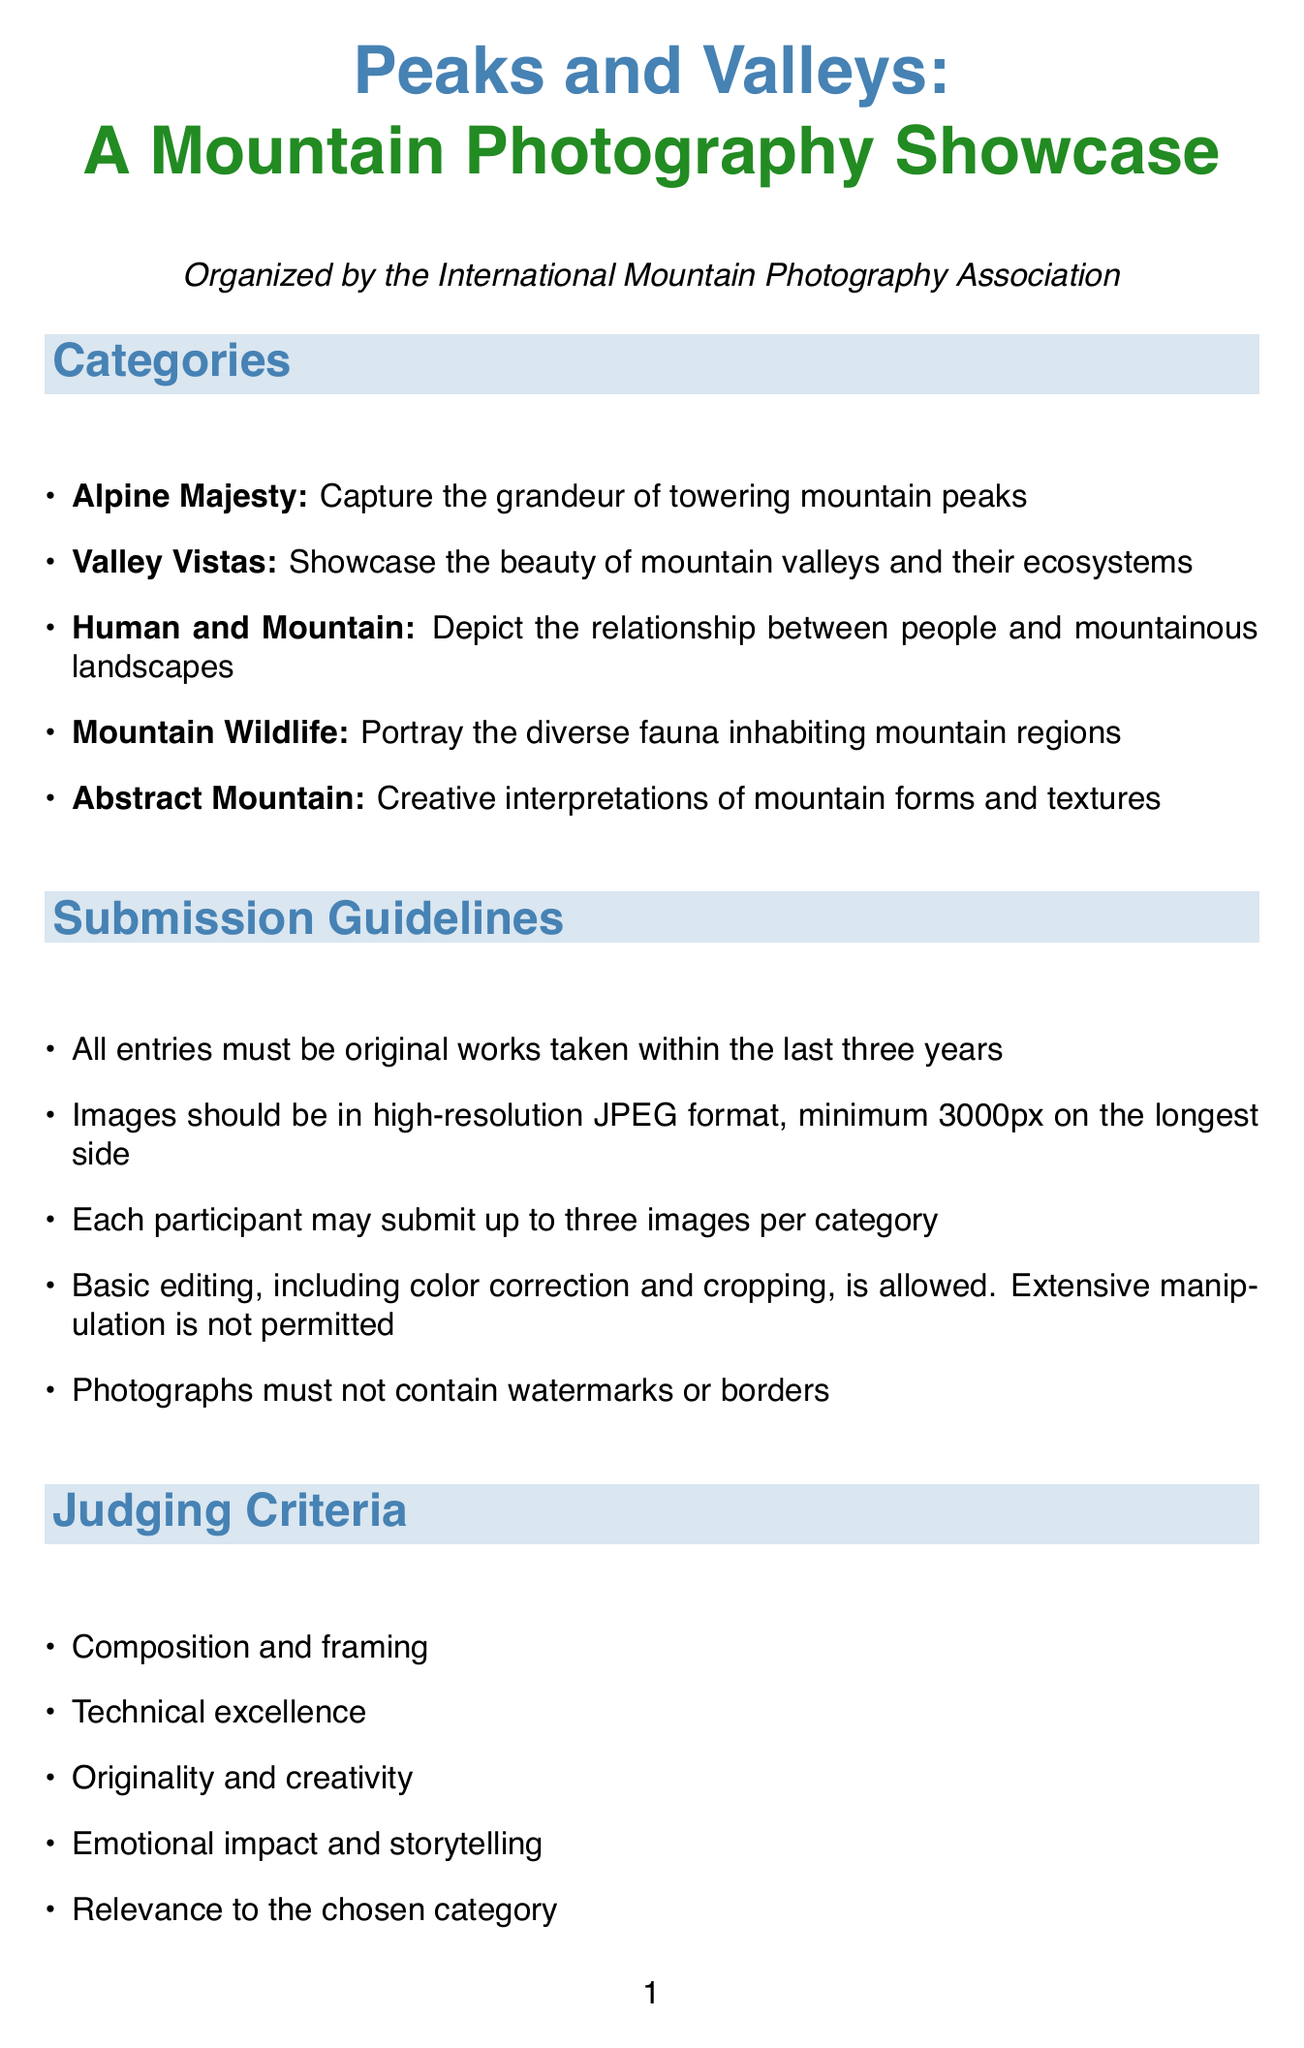What is the name of the photography contest? The name of the photography contest is mentioned at the beginning of the document.
Answer: Peaks and Valleys: A Mountain Photography Showcase Who organizes the contest? The organizing body is stated in the introduction.
Answer: International Mountain Photography Association What is the submission closing date? The closing date for submissions is specified in the important dates section.
Answer: August 31, 2023 How many images can each participant submit per category? The limit for submissions per category is outlined in the submission guidelines.
Answer: Three images What is the amount of the entry fee? The entry fee is listed explicitly in the document.
Answer: 25 USD What is one of the judging criteria? The judging criteria are detailed in a section and consist of multiple aspects.
Answer: Composition and framing What is the Grand Prize for the contest? The Grand Prize details can be found in the prizes section.
Answer: Nikon Z7 II Mirrorless Camera and a 2-week photography expedition to the Swiss Alps Where will the exhibition be held? The venue for the exhibition is given towards the end of the document.
Answer: The Ansel Adams Gallery, Yosemite National Park What rights do photographers grant by submitting their work? The terms and conditions specify the rights granted upon submission.
Answer: Non-exclusive rights to use submitted images for promotional purposes 